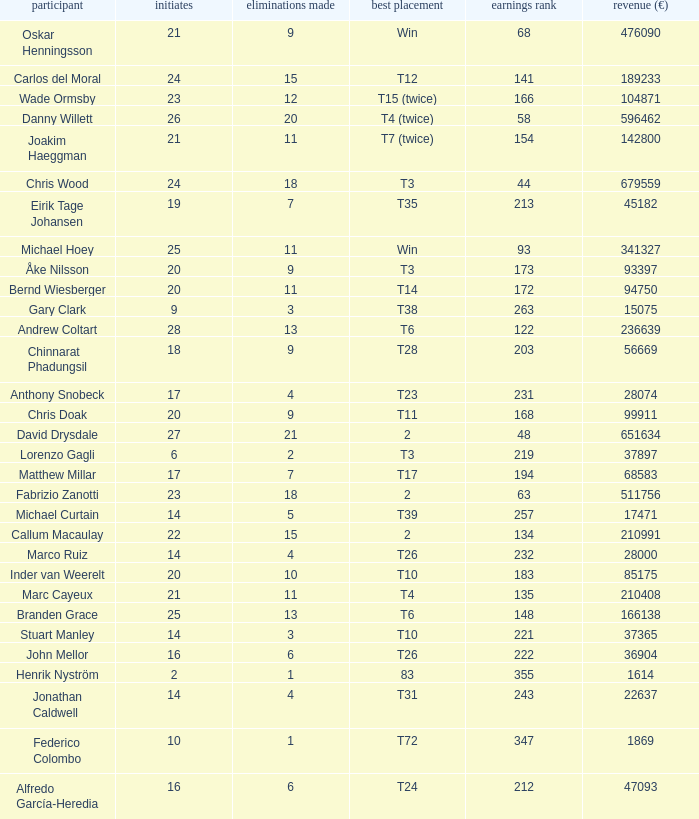How many cuts did Bernd Wiesberger make? 11.0. 